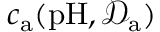Convert formula to latex. <formula><loc_0><loc_0><loc_500><loc_500>c _ { a } ( p H , \mathcal { D } _ { a } )</formula> 